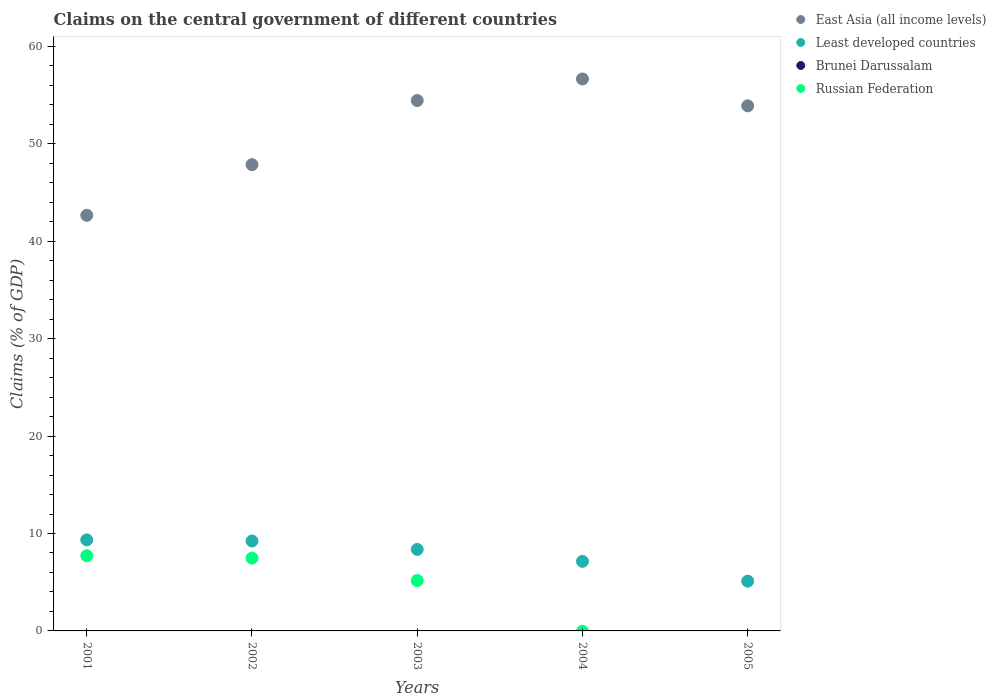How many different coloured dotlines are there?
Give a very brief answer. 3. What is the percentage of GDP claimed on the central government in Least developed countries in 2002?
Offer a terse response. 9.23. Across all years, what is the maximum percentage of GDP claimed on the central government in Least developed countries?
Offer a very short reply. 9.35. In which year was the percentage of GDP claimed on the central government in East Asia (all income levels) maximum?
Provide a short and direct response. 2004. What is the total percentage of GDP claimed on the central government in Brunei Darussalam in the graph?
Keep it short and to the point. 0. What is the difference between the percentage of GDP claimed on the central government in Least developed countries in 2002 and that in 2004?
Ensure brevity in your answer.  2.09. What is the difference between the percentage of GDP claimed on the central government in Brunei Darussalam in 2005 and the percentage of GDP claimed on the central government in East Asia (all income levels) in 2001?
Your response must be concise. -42.67. What is the average percentage of GDP claimed on the central government in Russian Federation per year?
Your answer should be very brief. 4.07. In the year 2003, what is the difference between the percentage of GDP claimed on the central government in Russian Federation and percentage of GDP claimed on the central government in East Asia (all income levels)?
Give a very brief answer. -49.28. In how many years, is the percentage of GDP claimed on the central government in Russian Federation greater than 58 %?
Offer a very short reply. 0. What is the ratio of the percentage of GDP claimed on the central government in Least developed countries in 2002 to that in 2005?
Your answer should be compact. 1.81. Is the percentage of GDP claimed on the central government in East Asia (all income levels) in 2004 less than that in 2005?
Your answer should be compact. No. Is the difference between the percentage of GDP claimed on the central government in Russian Federation in 2001 and 2003 greater than the difference between the percentage of GDP claimed on the central government in East Asia (all income levels) in 2001 and 2003?
Offer a very short reply. Yes. What is the difference between the highest and the second highest percentage of GDP claimed on the central government in Least developed countries?
Your response must be concise. 0.12. What is the difference between the highest and the lowest percentage of GDP claimed on the central government in East Asia (all income levels)?
Your answer should be compact. 14. Is the sum of the percentage of GDP claimed on the central government in East Asia (all income levels) in 2001 and 2005 greater than the maximum percentage of GDP claimed on the central government in Brunei Darussalam across all years?
Your response must be concise. Yes. Is it the case that in every year, the sum of the percentage of GDP claimed on the central government in Brunei Darussalam and percentage of GDP claimed on the central government in Least developed countries  is greater than the sum of percentage of GDP claimed on the central government in East Asia (all income levels) and percentage of GDP claimed on the central government in Russian Federation?
Keep it short and to the point. No. Is the percentage of GDP claimed on the central government in Brunei Darussalam strictly less than the percentage of GDP claimed on the central government in East Asia (all income levels) over the years?
Offer a very short reply. Yes. How many dotlines are there?
Make the answer very short. 3. Are the values on the major ticks of Y-axis written in scientific E-notation?
Offer a very short reply. No. Where does the legend appear in the graph?
Ensure brevity in your answer.  Top right. How are the legend labels stacked?
Make the answer very short. Vertical. What is the title of the graph?
Provide a short and direct response. Claims on the central government of different countries. Does "Czech Republic" appear as one of the legend labels in the graph?
Offer a very short reply. No. What is the label or title of the X-axis?
Your answer should be very brief. Years. What is the label or title of the Y-axis?
Keep it short and to the point. Claims (% of GDP). What is the Claims (% of GDP) of East Asia (all income levels) in 2001?
Keep it short and to the point. 42.67. What is the Claims (% of GDP) in Least developed countries in 2001?
Offer a terse response. 9.35. What is the Claims (% of GDP) of Russian Federation in 2001?
Your answer should be very brief. 7.72. What is the Claims (% of GDP) in East Asia (all income levels) in 2002?
Offer a very short reply. 47.87. What is the Claims (% of GDP) of Least developed countries in 2002?
Make the answer very short. 9.23. What is the Claims (% of GDP) in Russian Federation in 2002?
Offer a terse response. 7.48. What is the Claims (% of GDP) of East Asia (all income levels) in 2003?
Make the answer very short. 54.45. What is the Claims (% of GDP) of Least developed countries in 2003?
Your answer should be very brief. 8.37. What is the Claims (% of GDP) in Brunei Darussalam in 2003?
Make the answer very short. 0. What is the Claims (% of GDP) in Russian Federation in 2003?
Give a very brief answer. 5.17. What is the Claims (% of GDP) of East Asia (all income levels) in 2004?
Your answer should be compact. 56.67. What is the Claims (% of GDP) of Least developed countries in 2004?
Your response must be concise. 7.14. What is the Claims (% of GDP) in East Asia (all income levels) in 2005?
Your response must be concise. 53.91. What is the Claims (% of GDP) of Least developed countries in 2005?
Your answer should be compact. 5.11. What is the Claims (% of GDP) of Russian Federation in 2005?
Provide a short and direct response. 0. Across all years, what is the maximum Claims (% of GDP) in East Asia (all income levels)?
Ensure brevity in your answer.  56.67. Across all years, what is the maximum Claims (% of GDP) of Least developed countries?
Provide a succinct answer. 9.35. Across all years, what is the maximum Claims (% of GDP) in Russian Federation?
Offer a terse response. 7.72. Across all years, what is the minimum Claims (% of GDP) in East Asia (all income levels)?
Your response must be concise. 42.67. Across all years, what is the minimum Claims (% of GDP) of Least developed countries?
Provide a succinct answer. 5.11. Across all years, what is the minimum Claims (% of GDP) of Russian Federation?
Your answer should be very brief. 0. What is the total Claims (% of GDP) in East Asia (all income levels) in the graph?
Offer a terse response. 255.56. What is the total Claims (% of GDP) of Least developed countries in the graph?
Your answer should be very brief. 39.2. What is the total Claims (% of GDP) in Russian Federation in the graph?
Your response must be concise. 20.37. What is the difference between the Claims (% of GDP) in East Asia (all income levels) in 2001 and that in 2002?
Give a very brief answer. -5.2. What is the difference between the Claims (% of GDP) of Least developed countries in 2001 and that in 2002?
Make the answer very short. 0.12. What is the difference between the Claims (% of GDP) of Russian Federation in 2001 and that in 2002?
Your answer should be compact. 0.24. What is the difference between the Claims (% of GDP) in East Asia (all income levels) in 2001 and that in 2003?
Your answer should be compact. -11.78. What is the difference between the Claims (% of GDP) of Least developed countries in 2001 and that in 2003?
Keep it short and to the point. 0.98. What is the difference between the Claims (% of GDP) in Russian Federation in 2001 and that in 2003?
Give a very brief answer. 2.54. What is the difference between the Claims (% of GDP) of East Asia (all income levels) in 2001 and that in 2004?
Your response must be concise. -14. What is the difference between the Claims (% of GDP) in Least developed countries in 2001 and that in 2004?
Ensure brevity in your answer.  2.2. What is the difference between the Claims (% of GDP) in East Asia (all income levels) in 2001 and that in 2005?
Your answer should be very brief. -11.24. What is the difference between the Claims (% of GDP) in Least developed countries in 2001 and that in 2005?
Your answer should be compact. 4.24. What is the difference between the Claims (% of GDP) in East Asia (all income levels) in 2002 and that in 2003?
Your answer should be very brief. -6.58. What is the difference between the Claims (% of GDP) in Least developed countries in 2002 and that in 2003?
Provide a succinct answer. 0.86. What is the difference between the Claims (% of GDP) in Russian Federation in 2002 and that in 2003?
Provide a short and direct response. 2.3. What is the difference between the Claims (% of GDP) in East Asia (all income levels) in 2002 and that in 2004?
Offer a very short reply. -8.8. What is the difference between the Claims (% of GDP) in Least developed countries in 2002 and that in 2004?
Offer a terse response. 2.09. What is the difference between the Claims (% of GDP) in East Asia (all income levels) in 2002 and that in 2005?
Your answer should be very brief. -6.04. What is the difference between the Claims (% of GDP) in Least developed countries in 2002 and that in 2005?
Offer a terse response. 4.12. What is the difference between the Claims (% of GDP) of East Asia (all income levels) in 2003 and that in 2004?
Your response must be concise. -2.21. What is the difference between the Claims (% of GDP) in Least developed countries in 2003 and that in 2004?
Provide a short and direct response. 1.22. What is the difference between the Claims (% of GDP) of East Asia (all income levels) in 2003 and that in 2005?
Make the answer very short. 0.55. What is the difference between the Claims (% of GDP) of Least developed countries in 2003 and that in 2005?
Your answer should be very brief. 3.26. What is the difference between the Claims (% of GDP) in East Asia (all income levels) in 2004 and that in 2005?
Offer a very short reply. 2.76. What is the difference between the Claims (% of GDP) in Least developed countries in 2004 and that in 2005?
Offer a very short reply. 2.04. What is the difference between the Claims (% of GDP) in East Asia (all income levels) in 2001 and the Claims (% of GDP) in Least developed countries in 2002?
Ensure brevity in your answer.  33.44. What is the difference between the Claims (% of GDP) in East Asia (all income levels) in 2001 and the Claims (% of GDP) in Russian Federation in 2002?
Your answer should be compact. 35.19. What is the difference between the Claims (% of GDP) in Least developed countries in 2001 and the Claims (% of GDP) in Russian Federation in 2002?
Your answer should be compact. 1.87. What is the difference between the Claims (% of GDP) in East Asia (all income levels) in 2001 and the Claims (% of GDP) in Least developed countries in 2003?
Provide a succinct answer. 34.3. What is the difference between the Claims (% of GDP) in East Asia (all income levels) in 2001 and the Claims (% of GDP) in Russian Federation in 2003?
Provide a succinct answer. 37.5. What is the difference between the Claims (% of GDP) of Least developed countries in 2001 and the Claims (% of GDP) of Russian Federation in 2003?
Offer a very short reply. 4.18. What is the difference between the Claims (% of GDP) in East Asia (all income levels) in 2001 and the Claims (% of GDP) in Least developed countries in 2004?
Your response must be concise. 35.52. What is the difference between the Claims (% of GDP) of East Asia (all income levels) in 2001 and the Claims (% of GDP) of Least developed countries in 2005?
Give a very brief answer. 37.56. What is the difference between the Claims (% of GDP) in East Asia (all income levels) in 2002 and the Claims (% of GDP) in Least developed countries in 2003?
Your answer should be compact. 39.5. What is the difference between the Claims (% of GDP) in East Asia (all income levels) in 2002 and the Claims (% of GDP) in Russian Federation in 2003?
Give a very brief answer. 42.69. What is the difference between the Claims (% of GDP) in Least developed countries in 2002 and the Claims (% of GDP) in Russian Federation in 2003?
Provide a succinct answer. 4.06. What is the difference between the Claims (% of GDP) of East Asia (all income levels) in 2002 and the Claims (% of GDP) of Least developed countries in 2004?
Make the answer very short. 40.72. What is the difference between the Claims (% of GDP) of East Asia (all income levels) in 2002 and the Claims (% of GDP) of Least developed countries in 2005?
Your response must be concise. 42.76. What is the difference between the Claims (% of GDP) of East Asia (all income levels) in 2003 and the Claims (% of GDP) of Least developed countries in 2004?
Provide a succinct answer. 47.31. What is the difference between the Claims (% of GDP) of East Asia (all income levels) in 2003 and the Claims (% of GDP) of Least developed countries in 2005?
Give a very brief answer. 49.34. What is the difference between the Claims (% of GDP) in East Asia (all income levels) in 2004 and the Claims (% of GDP) in Least developed countries in 2005?
Keep it short and to the point. 51.56. What is the average Claims (% of GDP) in East Asia (all income levels) per year?
Give a very brief answer. 51.11. What is the average Claims (% of GDP) of Least developed countries per year?
Offer a very short reply. 7.84. What is the average Claims (% of GDP) of Russian Federation per year?
Give a very brief answer. 4.07. In the year 2001, what is the difference between the Claims (% of GDP) of East Asia (all income levels) and Claims (% of GDP) of Least developed countries?
Keep it short and to the point. 33.32. In the year 2001, what is the difference between the Claims (% of GDP) of East Asia (all income levels) and Claims (% of GDP) of Russian Federation?
Provide a succinct answer. 34.95. In the year 2001, what is the difference between the Claims (% of GDP) in Least developed countries and Claims (% of GDP) in Russian Federation?
Keep it short and to the point. 1.63. In the year 2002, what is the difference between the Claims (% of GDP) of East Asia (all income levels) and Claims (% of GDP) of Least developed countries?
Provide a short and direct response. 38.64. In the year 2002, what is the difference between the Claims (% of GDP) of East Asia (all income levels) and Claims (% of GDP) of Russian Federation?
Offer a very short reply. 40.39. In the year 2002, what is the difference between the Claims (% of GDP) of Least developed countries and Claims (% of GDP) of Russian Federation?
Give a very brief answer. 1.75. In the year 2003, what is the difference between the Claims (% of GDP) of East Asia (all income levels) and Claims (% of GDP) of Least developed countries?
Offer a terse response. 46.08. In the year 2003, what is the difference between the Claims (% of GDP) of East Asia (all income levels) and Claims (% of GDP) of Russian Federation?
Provide a succinct answer. 49.28. In the year 2003, what is the difference between the Claims (% of GDP) in Least developed countries and Claims (% of GDP) in Russian Federation?
Your answer should be compact. 3.2. In the year 2004, what is the difference between the Claims (% of GDP) of East Asia (all income levels) and Claims (% of GDP) of Least developed countries?
Offer a very short reply. 49.52. In the year 2005, what is the difference between the Claims (% of GDP) of East Asia (all income levels) and Claims (% of GDP) of Least developed countries?
Your response must be concise. 48.8. What is the ratio of the Claims (% of GDP) in East Asia (all income levels) in 2001 to that in 2002?
Your response must be concise. 0.89. What is the ratio of the Claims (% of GDP) in Least developed countries in 2001 to that in 2002?
Your response must be concise. 1.01. What is the ratio of the Claims (% of GDP) of Russian Federation in 2001 to that in 2002?
Provide a succinct answer. 1.03. What is the ratio of the Claims (% of GDP) of East Asia (all income levels) in 2001 to that in 2003?
Provide a succinct answer. 0.78. What is the ratio of the Claims (% of GDP) in Least developed countries in 2001 to that in 2003?
Offer a very short reply. 1.12. What is the ratio of the Claims (% of GDP) in Russian Federation in 2001 to that in 2003?
Ensure brevity in your answer.  1.49. What is the ratio of the Claims (% of GDP) of East Asia (all income levels) in 2001 to that in 2004?
Your response must be concise. 0.75. What is the ratio of the Claims (% of GDP) in Least developed countries in 2001 to that in 2004?
Offer a very short reply. 1.31. What is the ratio of the Claims (% of GDP) of East Asia (all income levels) in 2001 to that in 2005?
Keep it short and to the point. 0.79. What is the ratio of the Claims (% of GDP) of Least developed countries in 2001 to that in 2005?
Your answer should be very brief. 1.83. What is the ratio of the Claims (% of GDP) of East Asia (all income levels) in 2002 to that in 2003?
Your response must be concise. 0.88. What is the ratio of the Claims (% of GDP) of Least developed countries in 2002 to that in 2003?
Make the answer very short. 1.1. What is the ratio of the Claims (% of GDP) of Russian Federation in 2002 to that in 2003?
Your response must be concise. 1.45. What is the ratio of the Claims (% of GDP) of East Asia (all income levels) in 2002 to that in 2004?
Provide a succinct answer. 0.84. What is the ratio of the Claims (% of GDP) in Least developed countries in 2002 to that in 2004?
Your answer should be compact. 1.29. What is the ratio of the Claims (% of GDP) in East Asia (all income levels) in 2002 to that in 2005?
Provide a succinct answer. 0.89. What is the ratio of the Claims (% of GDP) in Least developed countries in 2002 to that in 2005?
Your answer should be very brief. 1.81. What is the ratio of the Claims (% of GDP) in East Asia (all income levels) in 2003 to that in 2004?
Ensure brevity in your answer.  0.96. What is the ratio of the Claims (% of GDP) of Least developed countries in 2003 to that in 2004?
Provide a short and direct response. 1.17. What is the ratio of the Claims (% of GDP) of East Asia (all income levels) in 2003 to that in 2005?
Provide a short and direct response. 1.01. What is the ratio of the Claims (% of GDP) in Least developed countries in 2003 to that in 2005?
Offer a very short reply. 1.64. What is the ratio of the Claims (% of GDP) in East Asia (all income levels) in 2004 to that in 2005?
Offer a terse response. 1.05. What is the ratio of the Claims (% of GDP) in Least developed countries in 2004 to that in 2005?
Your answer should be very brief. 1.4. What is the difference between the highest and the second highest Claims (% of GDP) of East Asia (all income levels)?
Ensure brevity in your answer.  2.21. What is the difference between the highest and the second highest Claims (% of GDP) in Least developed countries?
Your answer should be very brief. 0.12. What is the difference between the highest and the second highest Claims (% of GDP) of Russian Federation?
Ensure brevity in your answer.  0.24. What is the difference between the highest and the lowest Claims (% of GDP) in East Asia (all income levels)?
Ensure brevity in your answer.  14. What is the difference between the highest and the lowest Claims (% of GDP) in Least developed countries?
Your answer should be very brief. 4.24. What is the difference between the highest and the lowest Claims (% of GDP) of Russian Federation?
Your answer should be very brief. 7.72. 